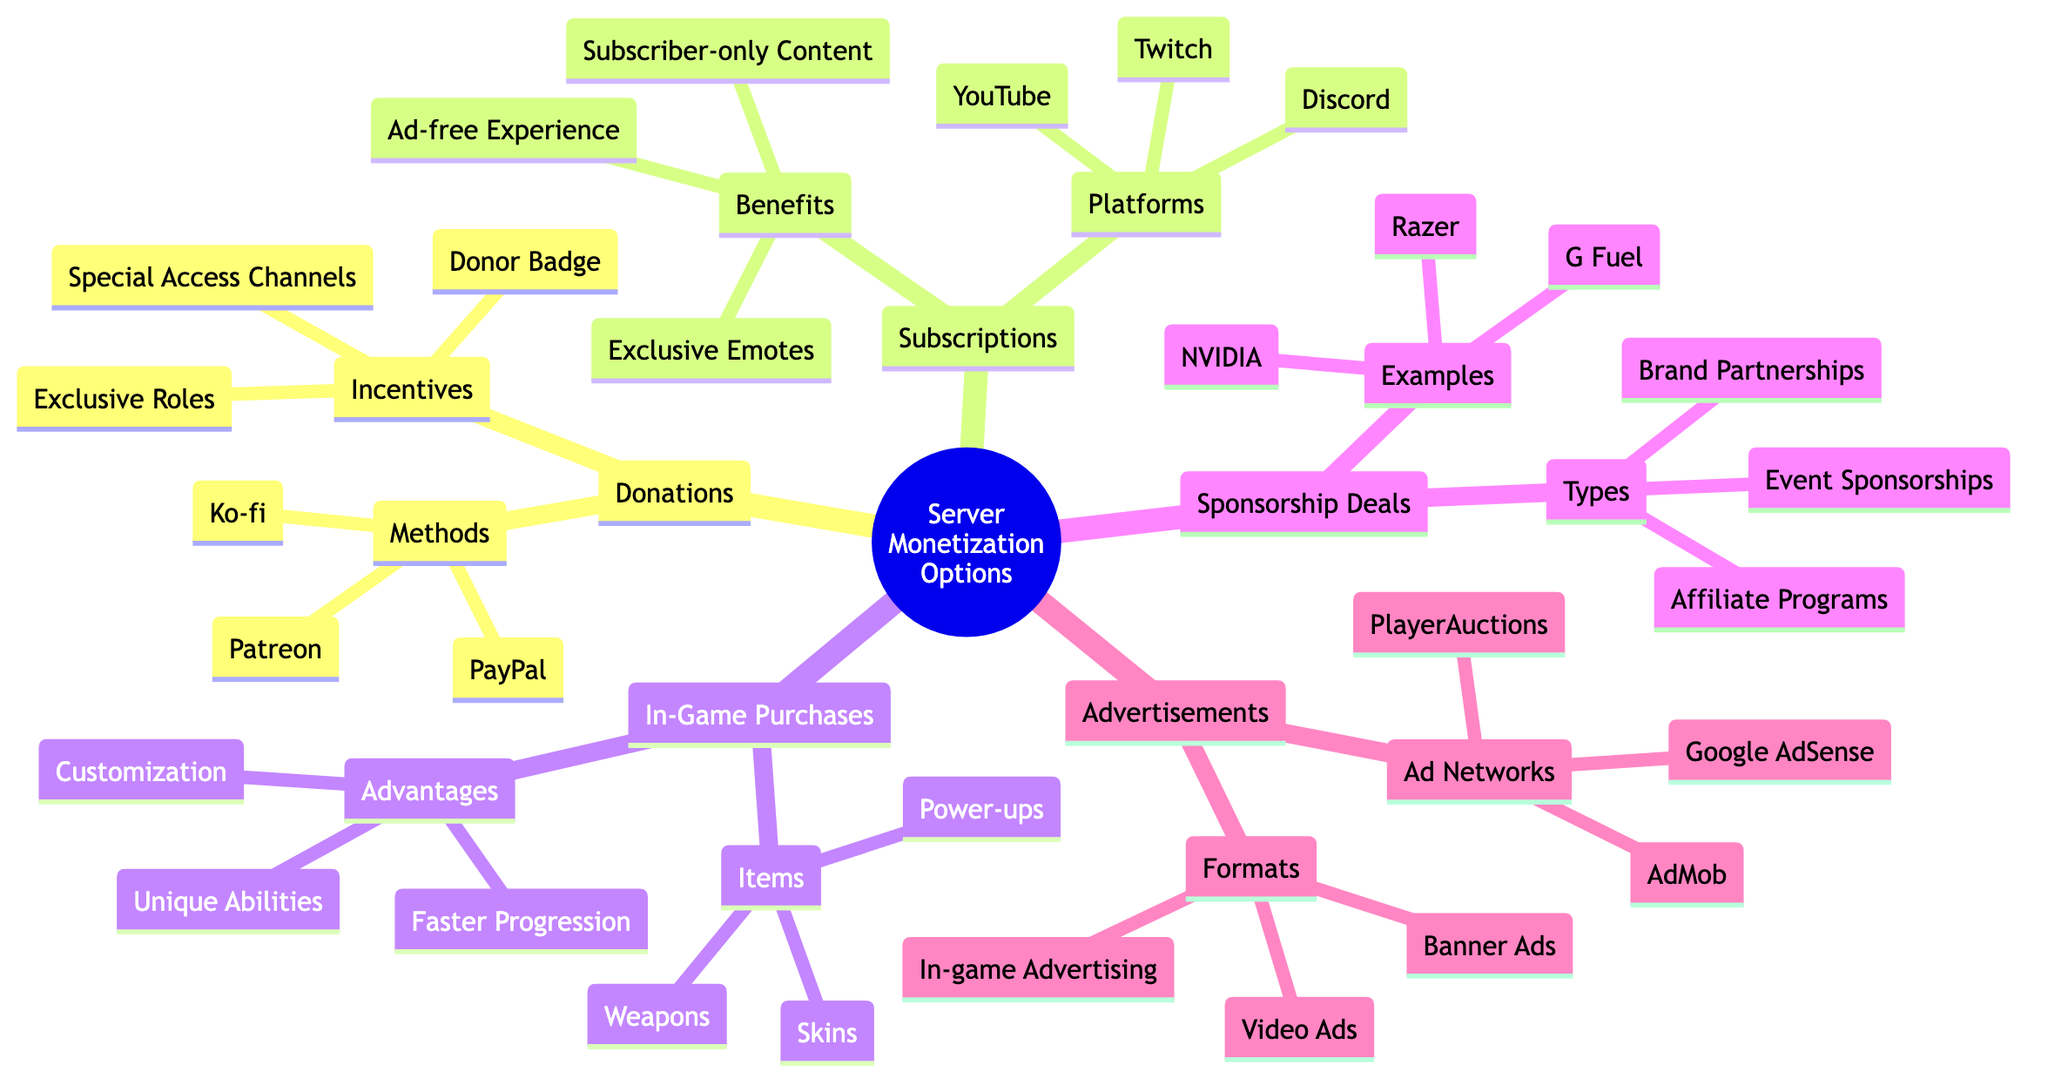What are the three methods of donations? By looking at the Donations node in the diagram, the sub-node Methods lists three items: Patreon, PayPal, and Ko-fi.
Answer: Patreon, PayPal, Ko-fi What are two platforms for subscriptions? The Subscriptions node has a sub-node called Platforms, which includes Twitch, YouTube, and Discord. Selecting any two of them serves the purpose.
Answer: Twitch, YouTube What types of sponsorship deals are there? The Sponsorship Deals node presents Types as a sub-node that contains Brand Partnerships, Event Sponsorships, and Affiliate Programs.
Answer: Brand Partnerships, Event Sponsorships, Affiliate Programs How many advantages are there for in-game purchases? Within the In-Game Purchases node, the sub-node Advantages lists three items: Customization, Faster Progression, and Unique Abilities. Therefore, there are three advantages.
Answer: 3 What is one benefit of subscriptions? By examining the Benefits sub-node under Subscriptions, we see three options: Ad-free Experience, Subscriber-only Content, and Exclusive Emotes. Selecting any one of them will answer the question.
Answer: Ad-free Experience How many ad formats are listed under advertisements? In the Advertisements node, the Formats sub-node lists three types: Banner Ads, Video Ads, and In-game Advertising. Therefore, there are three formats.
Answer: 3 Which ad network is listed as an option for advertisements? The Ad Networks sub-node under Advertisements includes Google AdSense, AdMob, and PlayerAuctions. Any one of these can be chosen to answer the question.
Answer: Google AdSense What is an incentive for donations? In the Donations node, the Incentives sub-node includes several items: Exclusive Roles, Special Access Channels, and Donor Badge. Any one of these serves as an answer.
Answer: Exclusive Roles What is the relationship between sponsorship deals and types? The Sponsorship Deals node has a clear sub-node called Types that categorizes various sponsorship arrangements within that node. This depicts a hierarchical relationship.
Answer: Types What items can be purchased in-game? The In-Game Purchases node shows a sub-node called Items, listing Skins, Weapons, and Power-ups. Any of these items can be named in the answer.
Answer: Skins 